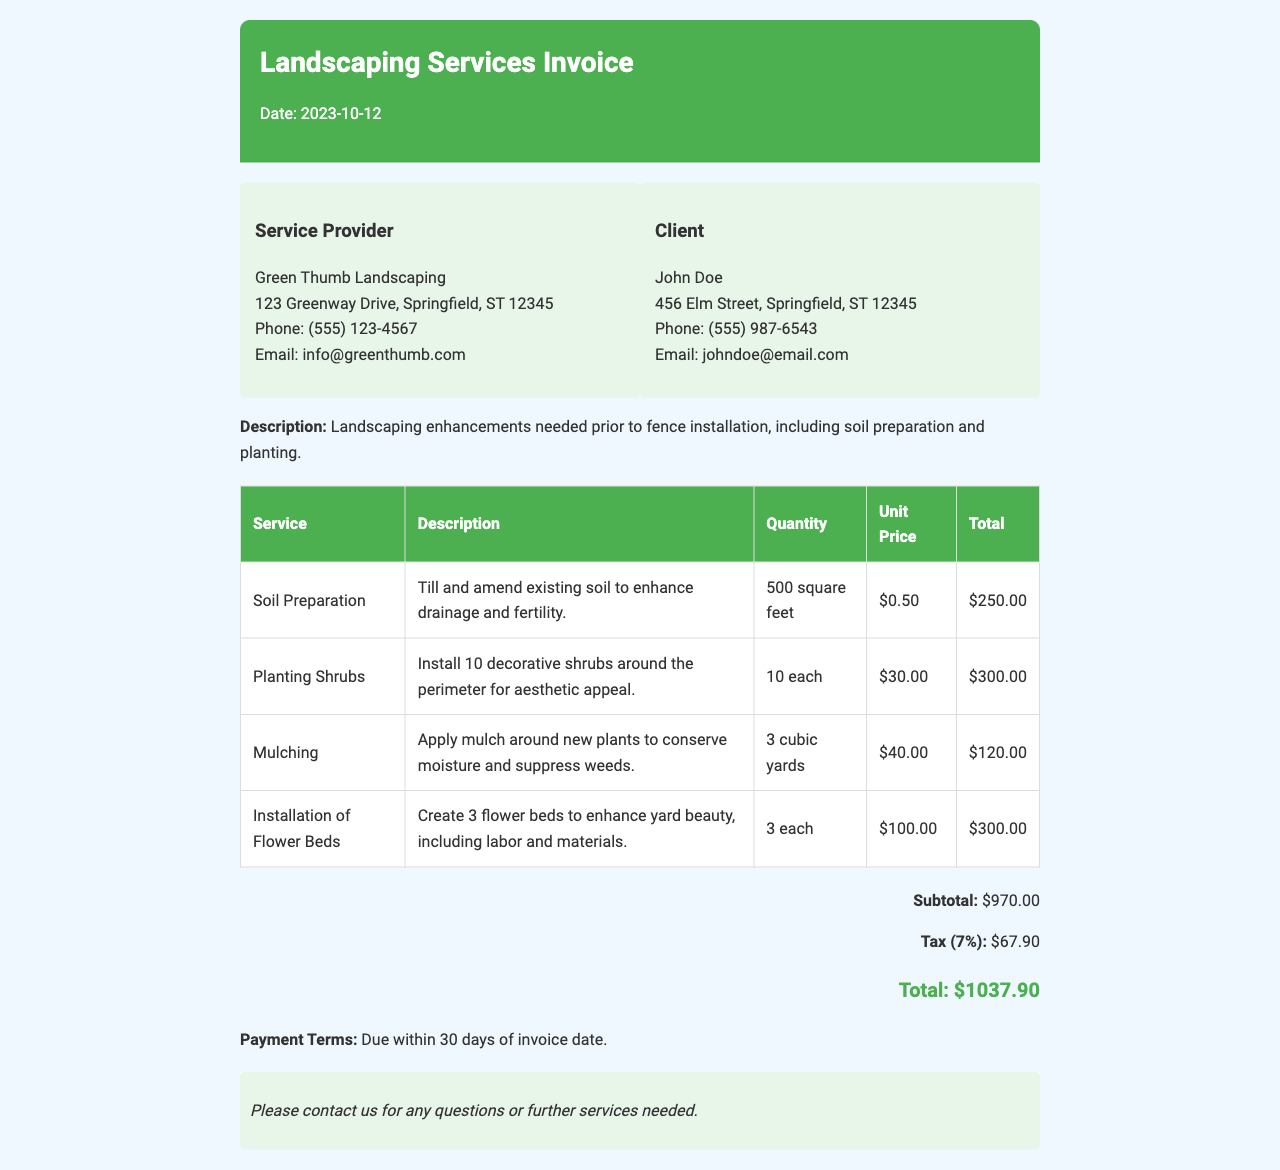What is the date of the invoice? The date of the invoice is mentioned at the top of the document.
Answer: 2023-10-12 Who is the service provider? The service provider's name is listed in the provider details section.
Answer: Green Thumb Landscaping What is the subtotal amount? The subtotal amount is stated in the total section of the invoice.
Answer: $970.00 How many shrubs are being planted? The number of shrubs being planted is specified in the description of the planting service.
Answer: 10 each What is the tax rate applied in the invoice? The tax rate is provided as a percentage in the total section.
Answer: 7% What is the total amount due? The total amount due is clearly listed in the total section of the invoice.
Answer: $1037.90 What services are included in the invoice? The services can be found in the table listing the service descriptions.
Answer: Soil Preparation, Planting Shrubs, Mulching, Installation of Flower Beds What are the payment terms? Payment terms are outlined at the end of the invoice.
Answer: Due within 30 days of invoice date How much is charged per cubic yard of mulch? The unit price for mulch is stated in the table of services.
Answer: $40.00 